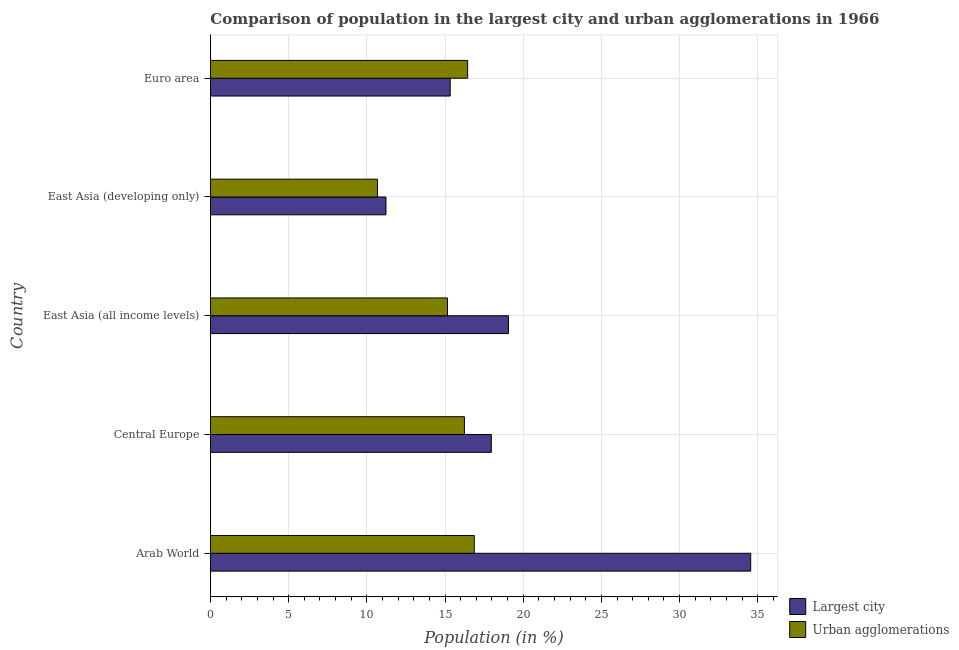Are the number of bars per tick equal to the number of legend labels?
Make the answer very short. Yes. What is the label of the 2nd group of bars from the top?
Ensure brevity in your answer.  East Asia (developing only). What is the population in the largest city in Euro area?
Keep it short and to the point. 15.33. Across all countries, what is the maximum population in the largest city?
Offer a terse response. 34.55. Across all countries, what is the minimum population in urban agglomerations?
Offer a very short reply. 10.68. In which country was the population in urban agglomerations maximum?
Provide a succinct answer. Arab World. In which country was the population in the largest city minimum?
Make the answer very short. East Asia (developing only). What is the total population in urban agglomerations in the graph?
Ensure brevity in your answer.  75.4. What is the difference between the population in urban agglomerations in Arab World and that in Central Europe?
Provide a short and direct response. 0.63. What is the difference between the population in urban agglomerations in Central Europe and the population in the largest city in East Asia (developing only)?
Keep it short and to the point. 5.02. What is the average population in urban agglomerations per country?
Your answer should be very brief. 15.08. What is the difference between the population in urban agglomerations and population in the largest city in Euro area?
Keep it short and to the point. 1.12. What is the ratio of the population in the largest city in Arab World to that in East Asia (all income levels)?
Your answer should be compact. 1.81. What is the difference between the highest and the second highest population in urban agglomerations?
Your response must be concise. 0.42. What is the difference between the highest and the lowest population in urban agglomerations?
Keep it short and to the point. 6.19. Is the sum of the population in the largest city in East Asia (developing only) and Euro area greater than the maximum population in urban agglomerations across all countries?
Give a very brief answer. Yes. What does the 2nd bar from the top in Central Europe represents?
Keep it short and to the point. Largest city. What does the 2nd bar from the bottom in East Asia (developing only) represents?
Provide a succinct answer. Urban agglomerations. Are all the bars in the graph horizontal?
Keep it short and to the point. Yes. What is the difference between two consecutive major ticks on the X-axis?
Give a very brief answer. 5. Are the values on the major ticks of X-axis written in scientific E-notation?
Ensure brevity in your answer.  No. Does the graph contain grids?
Make the answer very short. Yes. How many legend labels are there?
Offer a very short reply. 2. How are the legend labels stacked?
Offer a very short reply. Vertical. What is the title of the graph?
Offer a very short reply. Comparison of population in the largest city and urban agglomerations in 1966. What is the label or title of the Y-axis?
Your answer should be very brief. Country. What is the Population (in %) in Largest city in Arab World?
Make the answer very short. 34.55. What is the Population (in %) of Urban agglomerations in Arab World?
Your response must be concise. 16.87. What is the Population (in %) in Largest city in Central Europe?
Ensure brevity in your answer.  17.96. What is the Population (in %) of Urban agglomerations in Central Europe?
Make the answer very short. 16.24. What is the Population (in %) in Largest city in East Asia (all income levels)?
Provide a short and direct response. 19.06. What is the Population (in %) of Urban agglomerations in East Asia (all income levels)?
Provide a succinct answer. 15.16. What is the Population (in %) of Largest city in East Asia (developing only)?
Your answer should be compact. 11.22. What is the Population (in %) in Urban agglomerations in East Asia (developing only)?
Offer a very short reply. 10.68. What is the Population (in %) in Largest city in Euro area?
Ensure brevity in your answer.  15.33. What is the Population (in %) of Urban agglomerations in Euro area?
Provide a succinct answer. 16.45. Across all countries, what is the maximum Population (in %) in Largest city?
Offer a very short reply. 34.55. Across all countries, what is the maximum Population (in %) in Urban agglomerations?
Offer a terse response. 16.87. Across all countries, what is the minimum Population (in %) of Largest city?
Ensure brevity in your answer.  11.22. Across all countries, what is the minimum Population (in %) of Urban agglomerations?
Your answer should be very brief. 10.68. What is the total Population (in %) in Largest city in the graph?
Provide a succinct answer. 98.12. What is the total Population (in %) of Urban agglomerations in the graph?
Your answer should be compact. 75.4. What is the difference between the Population (in %) of Largest city in Arab World and that in Central Europe?
Make the answer very short. 16.59. What is the difference between the Population (in %) of Urban agglomerations in Arab World and that in Central Europe?
Provide a succinct answer. 0.63. What is the difference between the Population (in %) in Largest city in Arab World and that in East Asia (all income levels)?
Give a very brief answer. 15.49. What is the difference between the Population (in %) in Urban agglomerations in Arab World and that in East Asia (all income levels)?
Make the answer very short. 1.71. What is the difference between the Population (in %) of Largest city in Arab World and that in East Asia (developing only)?
Ensure brevity in your answer.  23.33. What is the difference between the Population (in %) in Urban agglomerations in Arab World and that in East Asia (developing only)?
Your response must be concise. 6.19. What is the difference between the Population (in %) in Largest city in Arab World and that in Euro area?
Offer a terse response. 19.22. What is the difference between the Population (in %) in Urban agglomerations in Arab World and that in Euro area?
Offer a terse response. 0.42. What is the difference between the Population (in %) in Largest city in Central Europe and that in East Asia (all income levels)?
Your answer should be compact. -1.1. What is the difference between the Population (in %) of Urban agglomerations in Central Europe and that in East Asia (all income levels)?
Give a very brief answer. 1.08. What is the difference between the Population (in %) of Largest city in Central Europe and that in East Asia (developing only)?
Give a very brief answer. 6.74. What is the difference between the Population (in %) in Urban agglomerations in Central Europe and that in East Asia (developing only)?
Your response must be concise. 5.56. What is the difference between the Population (in %) in Largest city in Central Europe and that in Euro area?
Your response must be concise. 2.63. What is the difference between the Population (in %) of Urban agglomerations in Central Europe and that in Euro area?
Your answer should be very brief. -0.21. What is the difference between the Population (in %) in Largest city in East Asia (all income levels) and that in East Asia (developing only)?
Your answer should be very brief. 7.84. What is the difference between the Population (in %) in Urban agglomerations in East Asia (all income levels) and that in East Asia (developing only)?
Make the answer very short. 4.48. What is the difference between the Population (in %) of Largest city in East Asia (all income levels) and that in Euro area?
Offer a terse response. 3.73. What is the difference between the Population (in %) of Urban agglomerations in East Asia (all income levels) and that in Euro area?
Your response must be concise. -1.29. What is the difference between the Population (in %) of Largest city in East Asia (developing only) and that in Euro area?
Ensure brevity in your answer.  -4.11. What is the difference between the Population (in %) in Urban agglomerations in East Asia (developing only) and that in Euro area?
Offer a very short reply. -5.77. What is the difference between the Population (in %) of Largest city in Arab World and the Population (in %) of Urban agglomerations in Central Europe?
Your answer should be compact. 18.31. What is the difference between the Population (in %) of Largest city in Arab World and the Population (in %) of Urban agglomerations in East Asia (all income levels)?
Ensure brevity in your answer.  19.39. What is the difference between the Population (in %) of Largest city in Arab World and the Population (in %) of Urban agglomerations in East Asia (developing only)?
Ensure brevity in your answer.  23.87. What is the difference between the Population (in %) in Largest city in Arab World and the Population (in %) in Urban agglomerations in Euro area?
Provide a succinct answer. 18.1. What is the difference between the Population (in %) in Largest city in Central Europe and the Population (in %) in Urban agglomerations in East Asia (all income levels)?
Offer a terse response. 2.8. What is the difference between the Population (in %) in Largest city in Central Europe and the Population (in %) in Urban agglomerations in East Asia (developing only)?
Keep it short and to the point. 7.28. What is the difference between the Population (in %) in Largest city in Central Europe and the Population (in %) in Urban agglomerations in Euro area?
Provide a short and direct response. 1.51. What is the difference between the Population (in %) in Largest city in East Asia (all income levels) and the Population (in %) in Urban agglomerations in East Asia (developing only)?
Keep it short and to the point. 8.38. What is the difference between the Population (in %) of Largest city in East Asia (all income levels) and the Population (in %) of Urban agglomerations in Euro area?
Ensure brevity in your answer.  2.61. What is the difference between the Population (in %) of Largest city in East Asia (developing only) and the Population (in %) of Urban agglomerations in Euro area?
Keep it short and to the point. -5.22. What is the average Population (in %) in Largest city per country?
Offer a terse response. 19.62. What is the average Population (in %) of Urban agglomerations per country?
Your response must be concise. 15.08. What is the difference between the Population (in %) of Largest city and Population (in %) of Urban agglomerations in Arab World?
Offer a terse response. 17.68. What is the difference between the Population (in %) of Largest city and Population (in %) of Urban agglomerations in Central Europe?
Provide a succinct answer. 1.72. What is the difference between the Population (in %) of Largest city and Population (in %) of Urban agglomerations in East Asia (all income levels)?
Keep it short and to the point. 3.9. What is the difference between the Population (in %) in Largest city and Population (in %) in Urban agglomerations in East Asia (developing only)?
Make the answer very short. 0.54. What is the difference between the Population (in %) of Largest city and Population (in %) of Urban agglomerations in Euro area?
Your response must be concise. -1.12. What is the ratio of the Population (in %) in Largest city in Arab World to that in Central Europe?
Offer a very short reply. 1.92. What is the ratio of the Population (in %) of Urban agglomerations in Arab World to that in Central Europe?
Make the answer very short. 1.04. What is the ratio of the Population (in %) in Largest city in Arab World to that in East Asia (all income levels)?
Make the answer very short. 1.81. What is the ratio of the Population (in %) of Urban agglomerations in Arab World to that in East Asia (all income levels)?
Give a very brief answer. 1.11. What is the ratio of the Population (in %) of Largest city in Arab World to that in East Asia (developing only)?
Your answer should be very brief. 3.08. What is the ratio of the Population (in %) of Urban agglomerations in Arab World to that in East Asia (developing only)?
Provide a short and direct response. 1.58. What is the ratio of the Population (in %) in Largest city in Arab World to that in Euro area?
Offer a terse response. 2.25. What is the ratio of the Population (in %) of Urban agglomerations in Arab World to that in Euro area?
Your answer should be very brief. 1.03. What is the ratio of the Population (in %) of Largest city in Central Europe to that in East Asia (all income levels)?
Ensure brevity in your answer.  0.94. What is the ratio of the Population (in %) in Urban agglomerations in Central Europe to that in East Asia (all income levels)?
Keep it short and to the point. 1.07. What is the ratio of the Population (in %) in Largest city in Central Europe to that in East Asia (developing only)?
Give a very brief answer. 1.6. What is the ratio of the Population (in %) in Urban agglomerations in Central Europe to that in East Asia (developing only)?
Offer a very short reply. 1.52. What is the ratio of the Population (in %) of Largest city in Central Europe to that in Euro area?
Ensure brevity in your answer.  1.17. What is the ratio of the Population (in %) in Urban agglomerations in Central Europe to that in Euro area?
Ensure brevity in your answer.  0.99. What is the ratio of the Population (in %) of Largest city in East Asia (all income levels) to that in East Asia (developing only)?
Make the answer very short. 1.7. What is the ratio of the Population (in %) of Urban agglomerations in East Asia (all income levels) to that in East Asia (developing only)?
Give a very brief answer. 1.42. What is the ratio of the Population (in %) of Largest city in East Asia (all income levels) to that in Euro area?
Provide a succinct answer. 1.24. What is the ratio of the Population (in %) of Urban agglomerations in East Asia (all income levels) to that in Euro area?
Your answer should be very brief. 0.92. What is the ratio of the Population (in %) of Largest city in East Asia (developing only) to that in Euro area?
Offer a very short reply. 0.73. What is the ratio of the Population (in %) in Urban agglomerations in East Asia (developing only) to that in Euro area?
Make the answer very short. 0.65. What is the difference between the highest and the second highest Population (in %) in Largest city?
Your answer should be very brief. 15.49. What is the difference between the highest and the second highest Population (in %) in Urban agglomerations?
Give a very brief answer. 0.42. What is the difference between the highest and the lowest Population (in %) of Largest city?
Keep it short and to the point. 23.33. What is the difference between the highest and the lowest Population (in %) in Urban agglomerations?
Give a very brief answer. 6.19. 